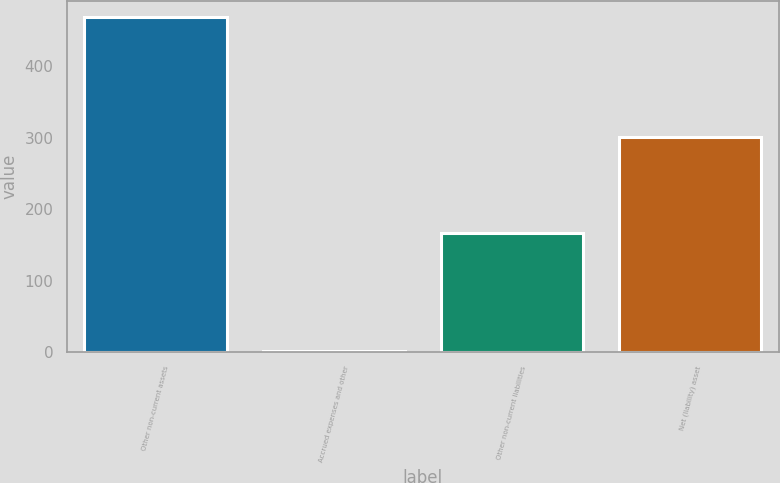Convert chart to OTSL. <chart><loc_0><loc_0><loc_500><loc_500><bar_chart><fcel>Other non-current assets<fcel>Accrued expenses and other<fcel>Other non-current liabilities<fcel>Net (liability) asset<nl><fcel>468<fcel>1<fcel>166<fcel>301<nl></chart> 